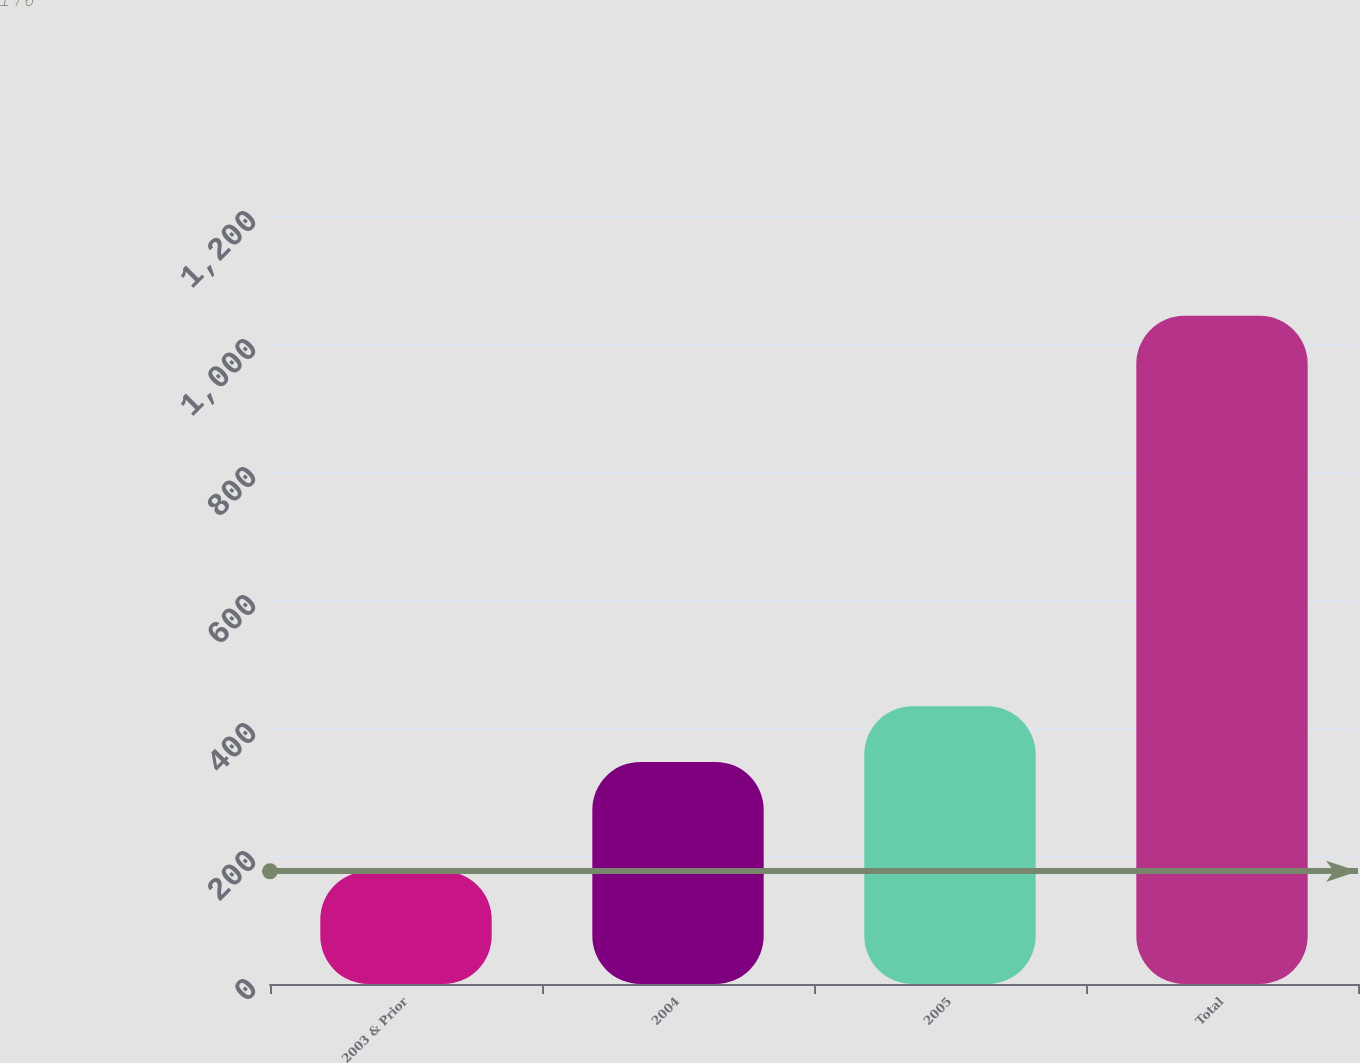<chart> <loc_0><loc_0><loc_500><loc_500><bar_chart><fcel>2003 & Prior<fcel>2004<fcel>2005<fcel>Total<nl><fcel>176<fcel>347<fcel>433.8<fcel>1044<nl></chart> 